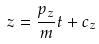<formula> <loc_0><loc_0><loc_500><loc_500>z = \frac { p _ { z } } { m } t + c _ { z }</formula> 